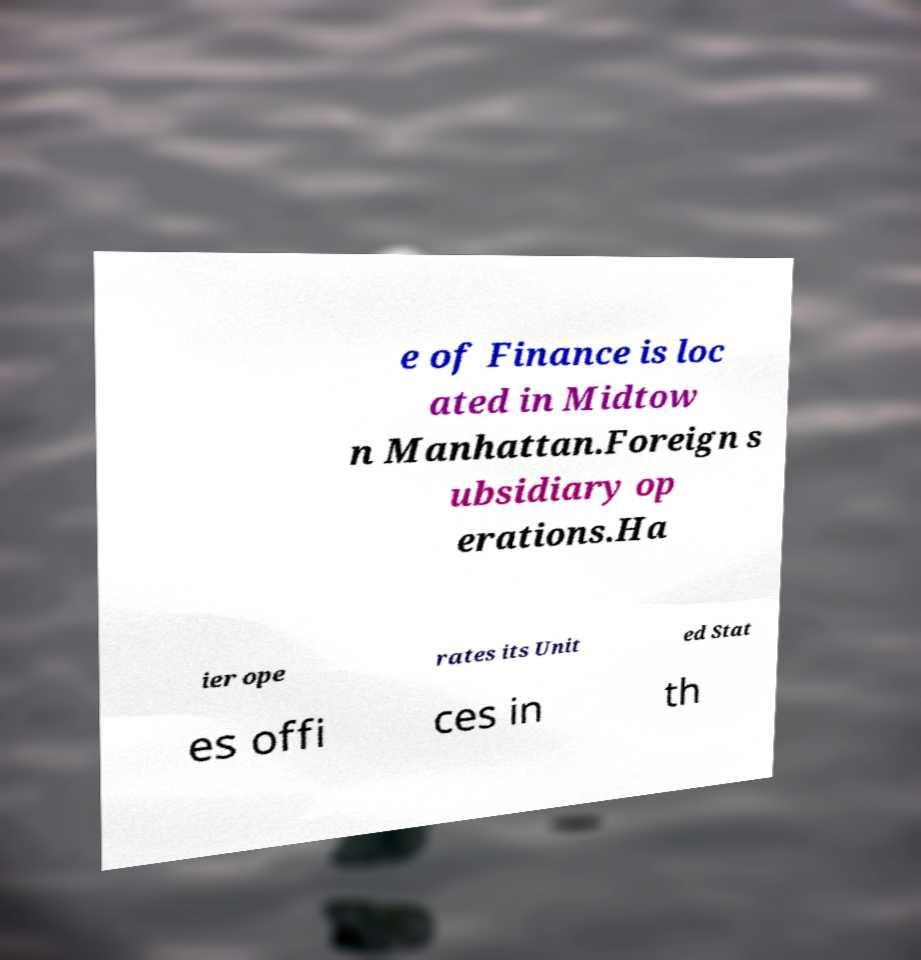Could you assist in decoding the text presented in this image and type it out clearly? e of Finance is loc ated in Midtow n Manhattan.Foreign s ubsidiary op erations.Ha ier ope rates its Unit ed Stat es offi ces in th 